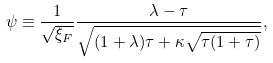<formula> <loc_0><loc_0><loc_500><loc_500>\psi \equiv \frac { 1 } { \sqrt { \xi _ { F } } } \frac { \lambda - \tau } { \sqrt { ( 1 + \lambda ) \tau + \kappa \sqrt { \tau ( 1 + \tau ) } } } ,</formula> 